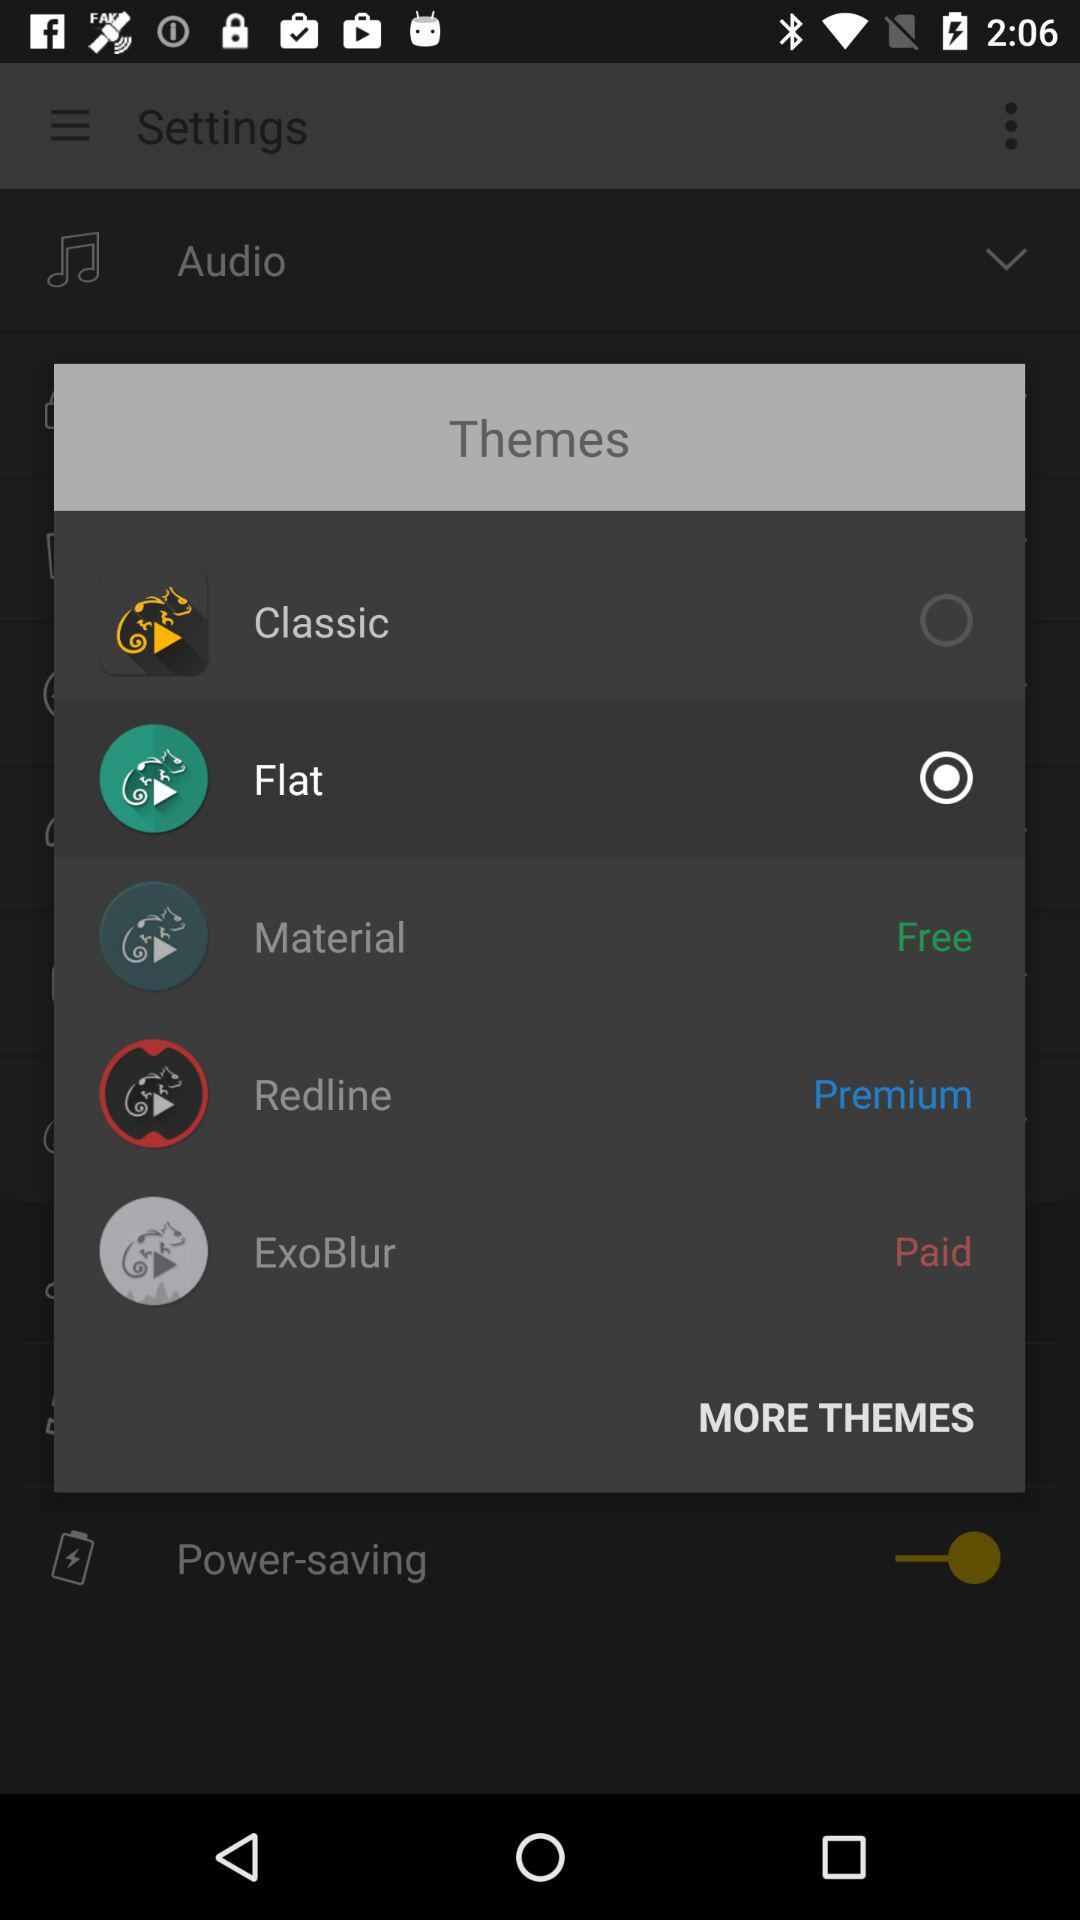What is the selected theme? The selected theme is "Flat". 